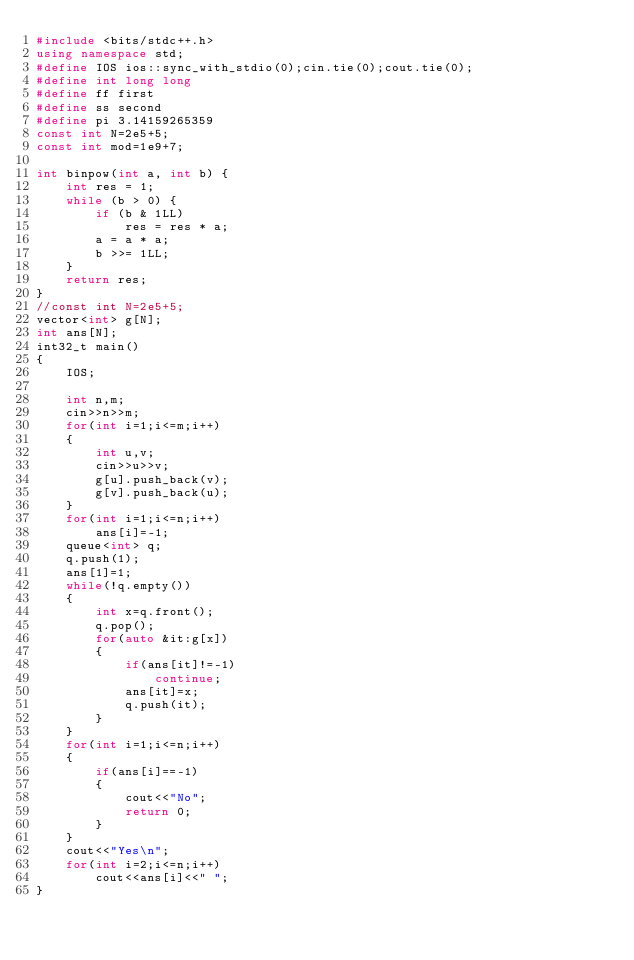<code> <loc_0><loc_0><loc_500><loc_500><_C++_>#include <bits/stdc++.h>
using namespace std;
#define IOS ios::sync_with_stdio(0);cin.tie(0);cout.tie(0);
#define int long long
#define ff first
#define ss second
#define pi 3.14159265359 
const int N=2e5+5;
const int mod=1e9+7;
 
int binpow(int a, int b) {
    int res = 1;
    while (b > 0) {
        if (b & 1LL)
            res = res * a;
        a = a * a;
        b >>= 1LL;
    }
    return res;
}
//const int N=2e5+5;
vector<int> g[N];
int ans[N];
int32_t main()
{
    IOS;
    
    int n,m;
    cin>>n>>m;
    for(int i=1;i<=m;i++)
    {
        int u,v;
        cin>>u>>v;
        g[u].push_back(v);
        g[v].push_back(u);
    }
    for(int i=1;i<=n;i++)
        ans[i]=-1;
    queue<int> q;
    q.push(1);
    ans[1]=1;
    while(!q.empty())
    {
        int x=q.front();
        q.pop();
        for(auto &it:g[x])
        {
            if(ans[it]!=-1)
                continue;
            ans[it]=x;
            q.push(it);
        }
    }
    for(int i=1;i<=n;i++)
    {
        if(ans[i]==-1)
        {
            cout<<"No";
            return 0;
        }
    }
    cout<<"Yes\n";
    for(int i=2;i<=n;i++)
        cout<<ans[i]<<" ";
}</code> 